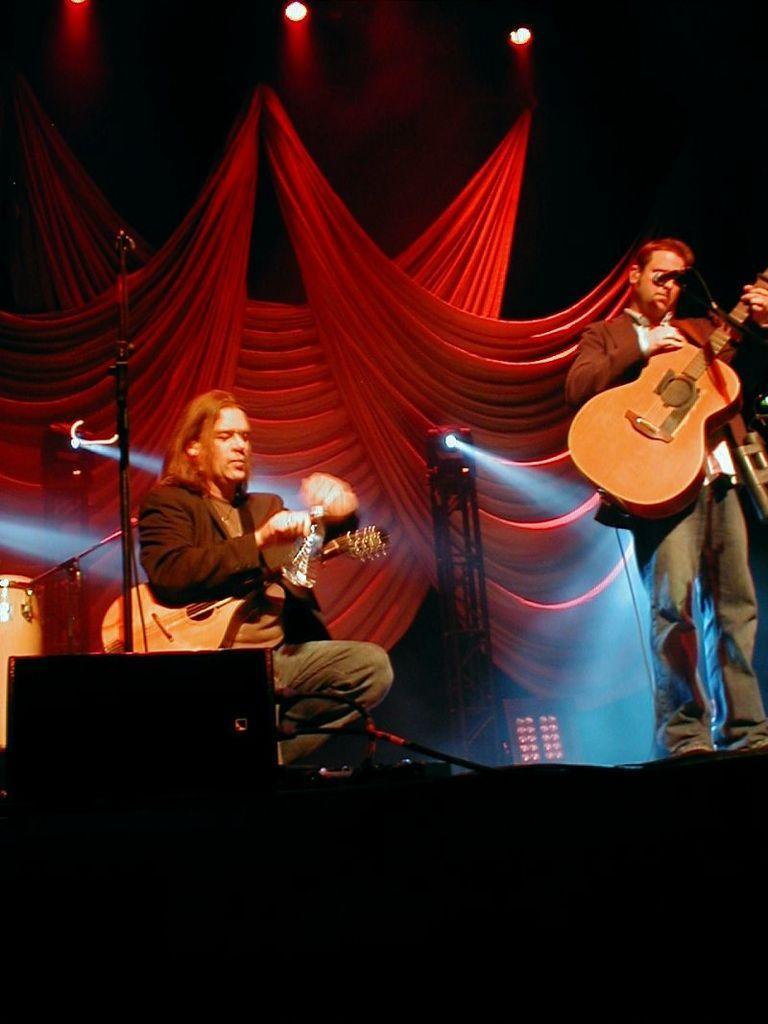In one or two sentences, can you explain what this image depicts? on the stage 2 people are present, they are holding guitars in their hands. the person at the left is sitting and holding a water bottle. the person at the right is standing. there is a microphone present in front of him. at the back there are red curtains and lights. at the left there are drums. 